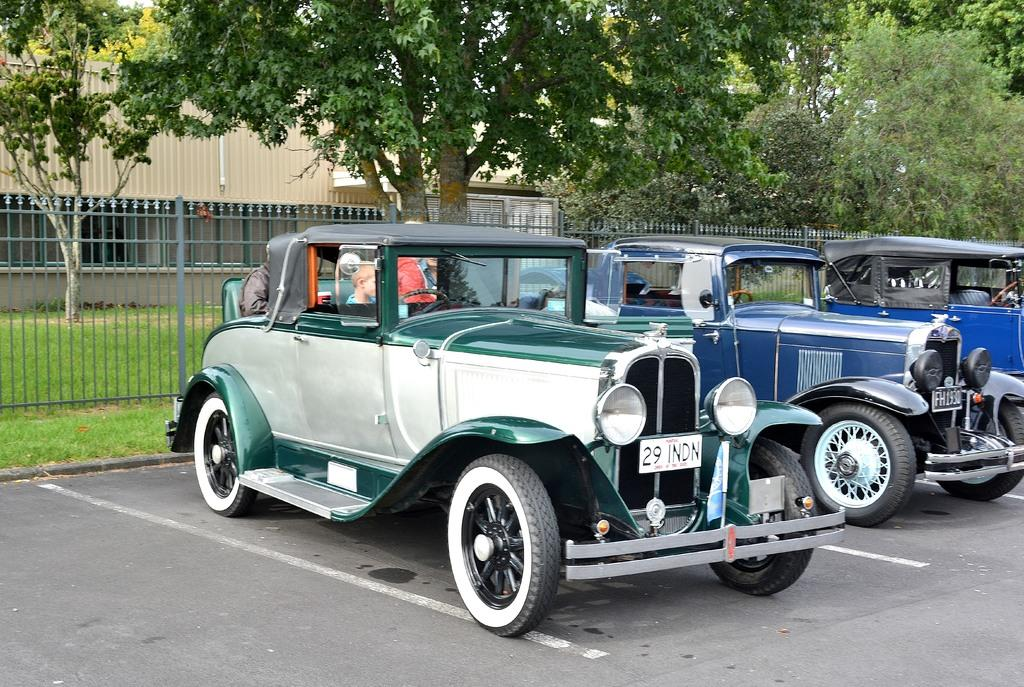What can be seen on the road in the image? There are vehicles parked on the road in the image. Who or what can be seen in the image besides the vehicles? There are people visible in the image. What can be seen in the background of the image? In the background, there is a grill, walls, houses, windows, and trees. What type of riddle can be seen on the neck of the person in the image? There is no riddle or necklace visible in the image; it only shows vehicles parked on the road, people, and the background. What kind of lace is draped over the windows in the image? There is no lace present in the image; only windows are visible in the background. 